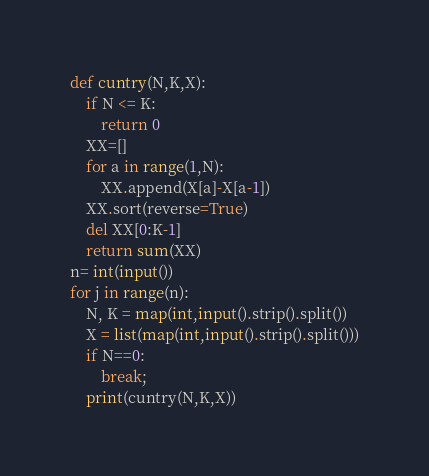Convert code to text. <code><loc_0><loc_0><loc_500><loc_500><_Python_>def cuntry(N,K,X):
    if N <= K:
        return 0
    XX=[]
    for a in range(1,N):
        XX.append(X[a]-X[a-1])
    XX.sort(reverse=True)
    del XX[0:K-1]
    return sum(XX)
n= int(input())  
for j in range(n):
    N, K = map(int,input().strip().split())
    X = list(map(int,input().strip().split()))
    if N==0:
        break;
    print(cuntry(N,K,X))
</code> 